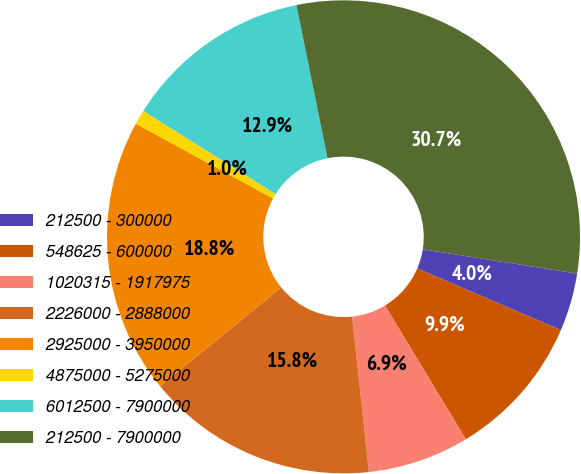Convert chart to OTSL. <chart><loc_0><loc_0><loc_500><loc_500><pie_chart><fcel>212500 - 300000<fcel>548625 - 600000<fcel>1020315 - 1917975<fcel>2226000 - 2888000<fcel>2925000 - 3950000<fcel>4875000 - 5275000<fcel>6012500 - 7900000<fcel>212500 - 7900000<nl><fcel>3.97%<fcel>9.9%<fcel>6.94%<fcel>15.84%<fcel>18.81%<fcel>1.0%<fcel>12.87%<fcel>30.67%<nl></chart> 